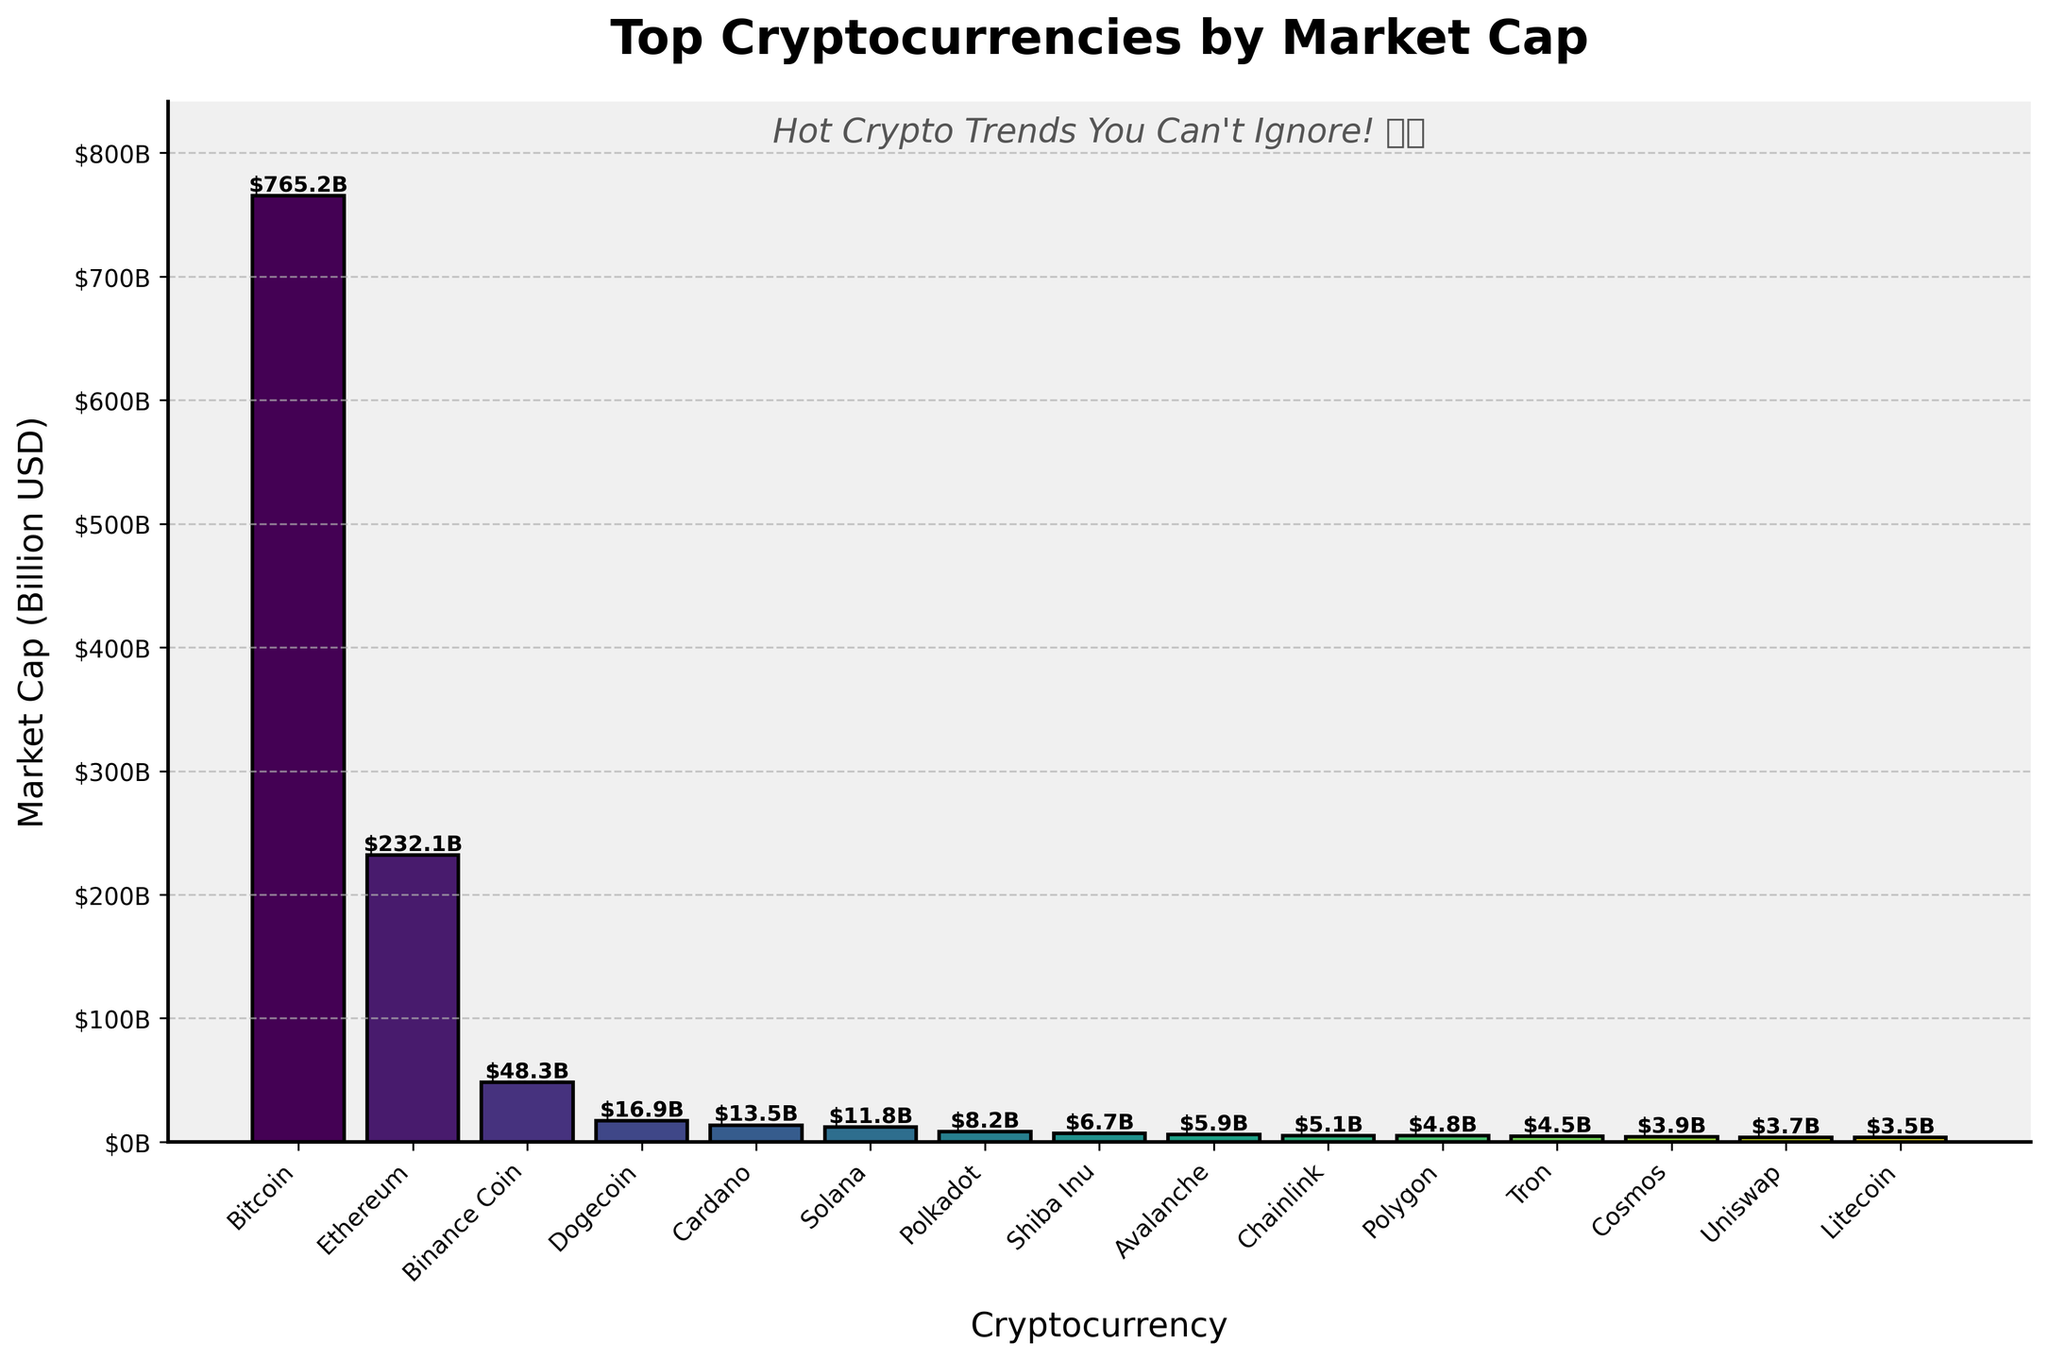What's the market cap of Solana? Solana is one of the bars in the plot, and its height can be read off the y-axis. The label on the top of Solana's bar also indicates its market capitalization directly.
Answer: $11.8B Compare the market cap of Dogecoin to that of Shiba Inu. Which one is higher and by how much? To compare the two, look at the height of the bars for Dogecoin and Shiba Inu. Dogecoin's bar reaches $16.9B, whereas Shiba Inu's bar reaches $6.7B. Subtracting the two values gives the difference.
Answer: Dogecoin, $10.2B What is the combined market cap of Binance Coin and Cardano? Add the market capitalizations of Binance Coin ($48.3B) and Cardano ($13.5B) by summing their values from the bar labels.
Answer: $61.8B How does the market cap of Ethereum compare to that of Bitcoin? The height of Ethereum's bar shows it has a market cap of $232.1B, while Bitcoin's bar shows $765.2B. By comparing these, Bitcoin’s market cap is higher.
Answer: Bitcoin is higher by $533.1B What is the market cap of the smallest cryptocurrency shown in the plot? The smallest cryptocurrency by market cap can be identified by finding the shortest bar. The bar representing Litecoin shows the smallest height, with a market capitalization of $3.5B.
Answer: $3.5B How many cryptocurrencies have a market cap greater than $10B? To answer this, count the number of bars whose height exceeds the $10B mark on the y-axis. The bars for Bitcoin, Ethereum, Binance Coin, Dogecoin, Cardano, and Solana are above this threshold.
Answer: 6 Which cryptocurrency has a market cap closest to $5B, and what is the exact value? By checking the heights of the bars around the $5B mark, Chainlink has a market cap close to $5B (specifically $5.1B).
Answer: Chainlink, $5.1B What is the average market cap of the cryptocurrencies listed in the plot? Sum the market caps of all cryptocurrencies (765.2 + 232.1 + 48.3 + 16.9 + 13.5 + 11.8 + 8.2 + 6.7 + 5.9 + 5.1 + 4.8 + 4.5 + 3.9 + 3.7 + 3.5 = 1134.10) and divide by the number of cryptocurrencies (15).
Answer: $75.6B What is the range of the market capitalizations shown in the plot? The range can be found by subtracting the smallest market cap ($3.5B for Litecoin) from the largest market cap ($765.2B for Bitcoin).
Answer: $761.7B 